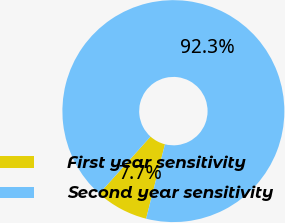Convert chart to OTSL. <chart><loc_0><loc_0><loc_500><loc_500><pie_chart><fcel>First year sensitivity<fcel>Second year sensitivity<nl><fcel>7.69%<fcel>92.31%<nl></chart> 